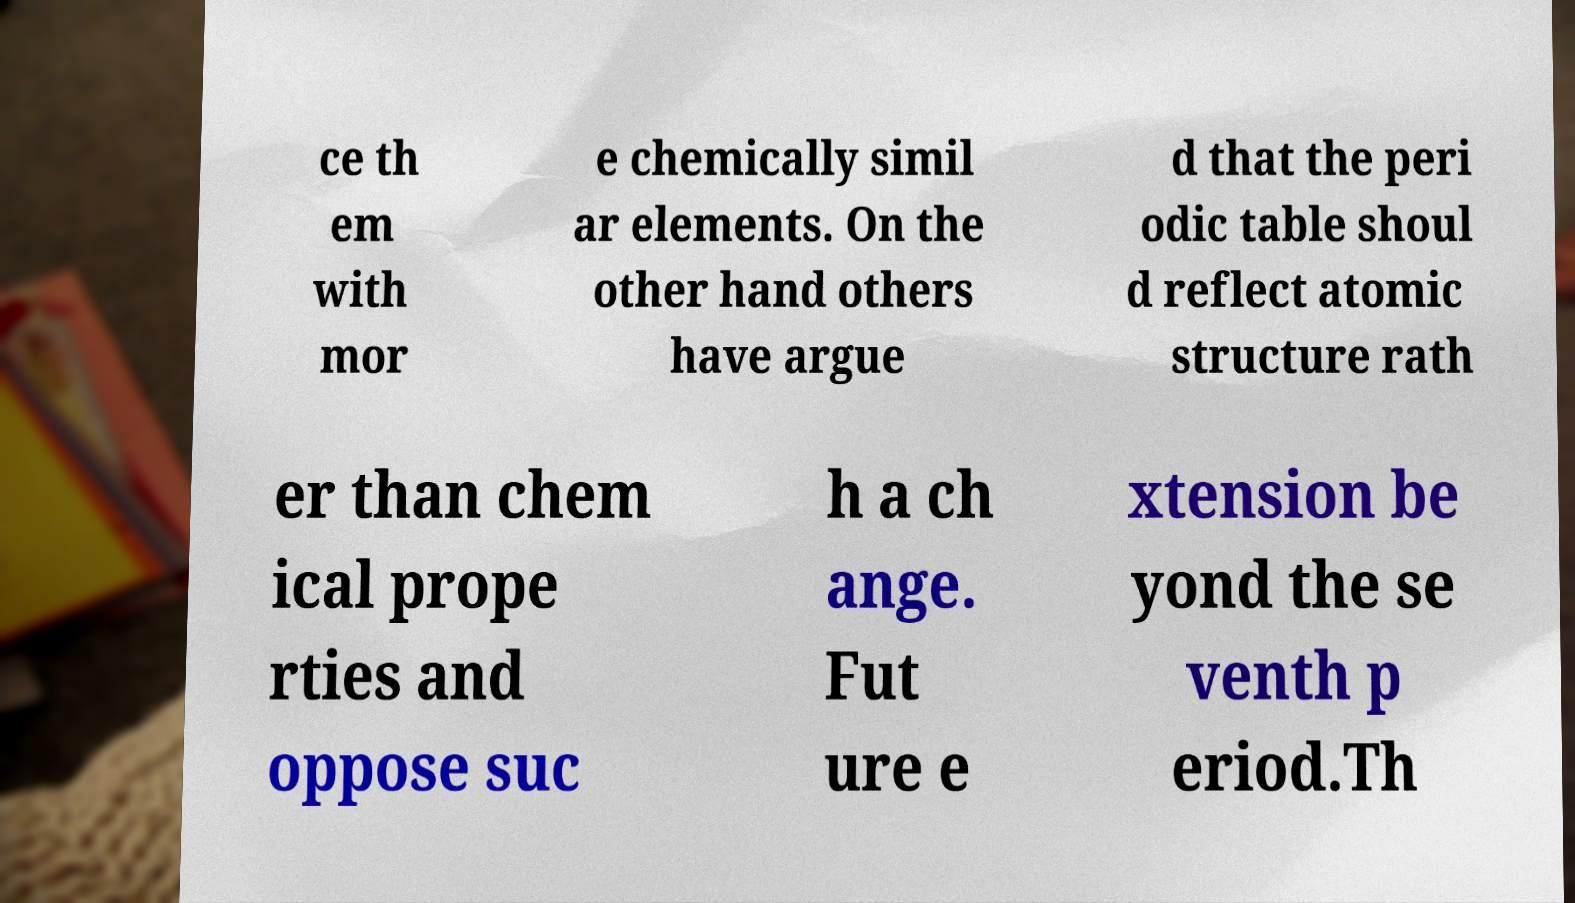There's text embedded in this image that I need extracted. Can you transcribe it verbatim? ce th em with mor e chemically simil ar elements. On the other hand others have argue d that the peri odic table shoul d reflect atomic structure rath er than chem ical prope rties and oppose suc h a ch ange. Fut ure e xtension be yond the se venth p eriod.Th 